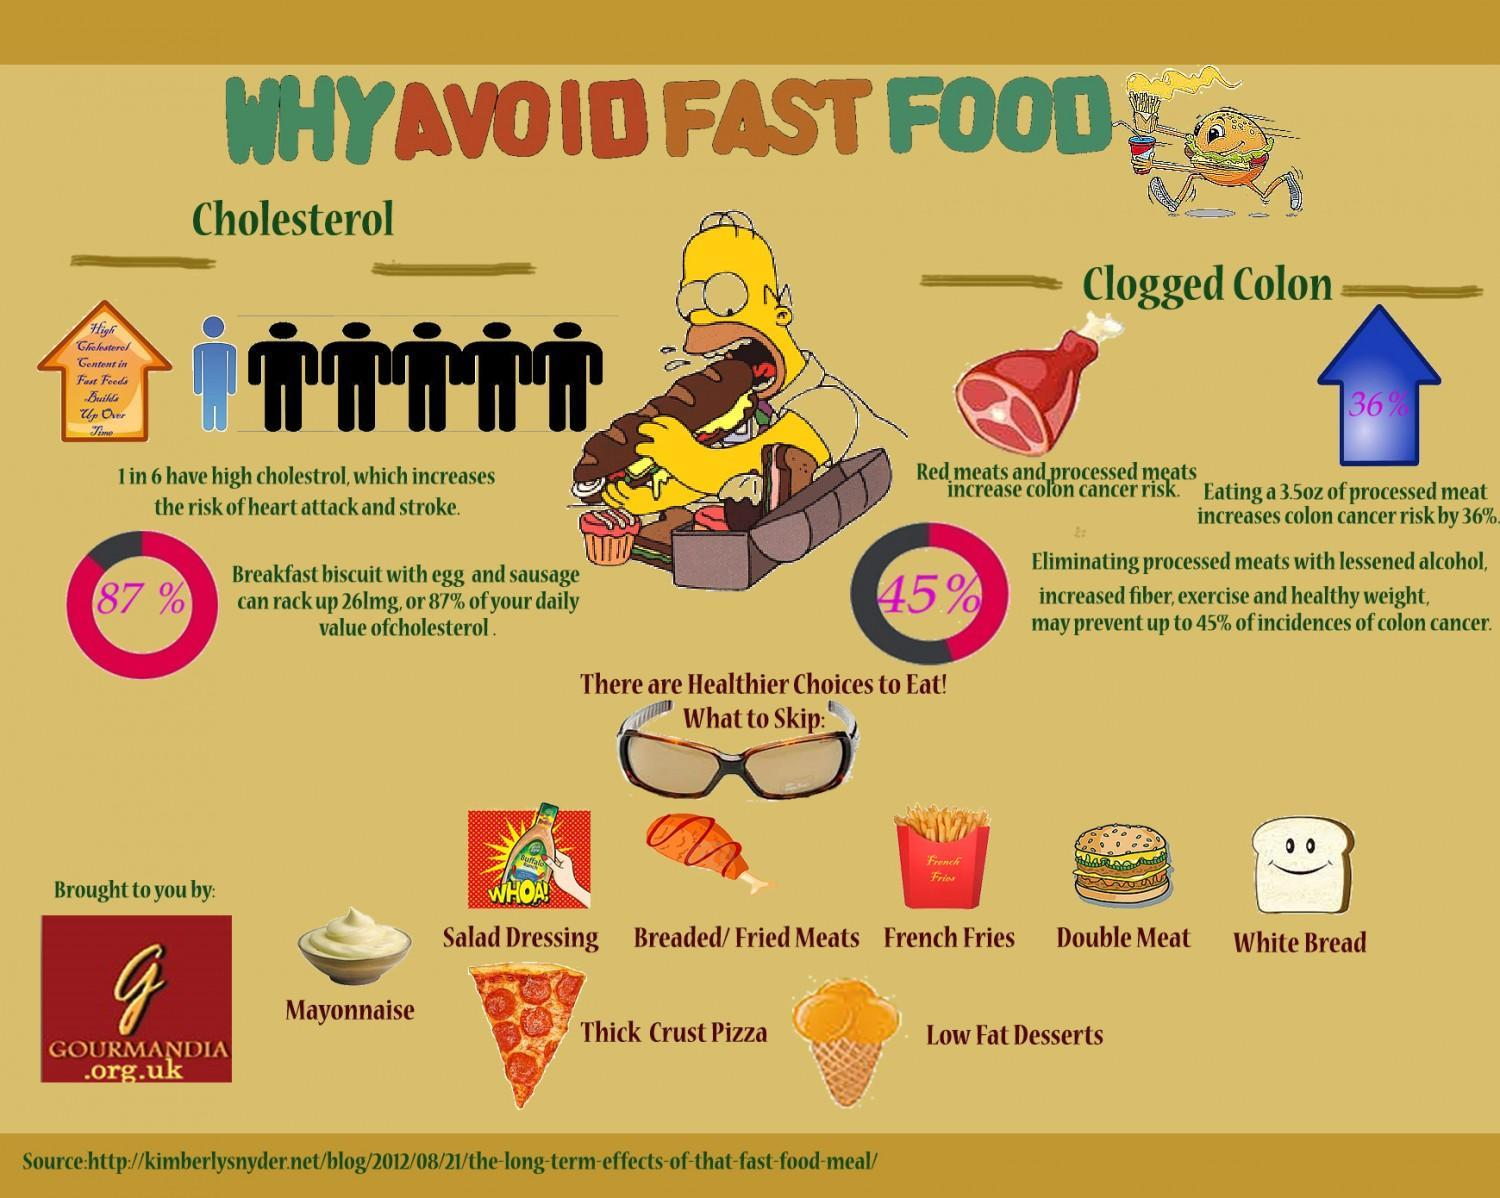WHat is written inside the blue arrow
Answer the question with a short phrase. 36% what is written in the yellow arrow high cholesterol content in fast foods builds up over time What are the two main risks due to fast food cholesterol, clogged colon WHat type of food is indicated by the chicken leg breaded/ fried meats what is the colour of the bread, white or brown white 